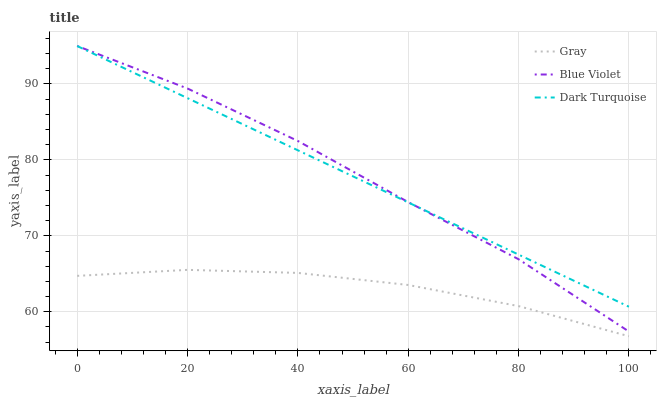Does Gray have the minimum area under the curve?
Answer yes or no. Yes. Does Blue Violet have the maximum area under the curve?
Answer yes or no. Yes. Does Dark Turquoise have the minimum area under the curve?
Answer yes or no. No. Does Dark Turquoise have the maximum area under the curve?
Answer yes or no. No. Is Dark Turquoise the smoothest?
Answer yes or no. Yes. Is Blue Violet the roughest?
Answer yes or no. Yes. Is Blue Violet the smoothest?
Answer yes or no. No. Is Dark Turquoise the roughest?
Answer yes or no. No. Does Blue Violet have the lowest value?
Answer yes or no. No. Does Dark Turquoise have the highest value?
Answer yes or no. Yes. Is Gray less than Dark Turquoise?
Answer yes or no. Yes. Is Dark Turquoise greater than Gray?
Answer yes or no. Yes. Does Blue Violet intersect Dark Turquoise?
Answer yes or no. Yes. Is Blue Violet less than Dark Turquoise?
Answer yes or no. No. Is Blue Violet greater than Dark Turquoise?
Answer yes or no. No. Does Gray intersect Dark Turquoise?
Answer yes or no. No. 